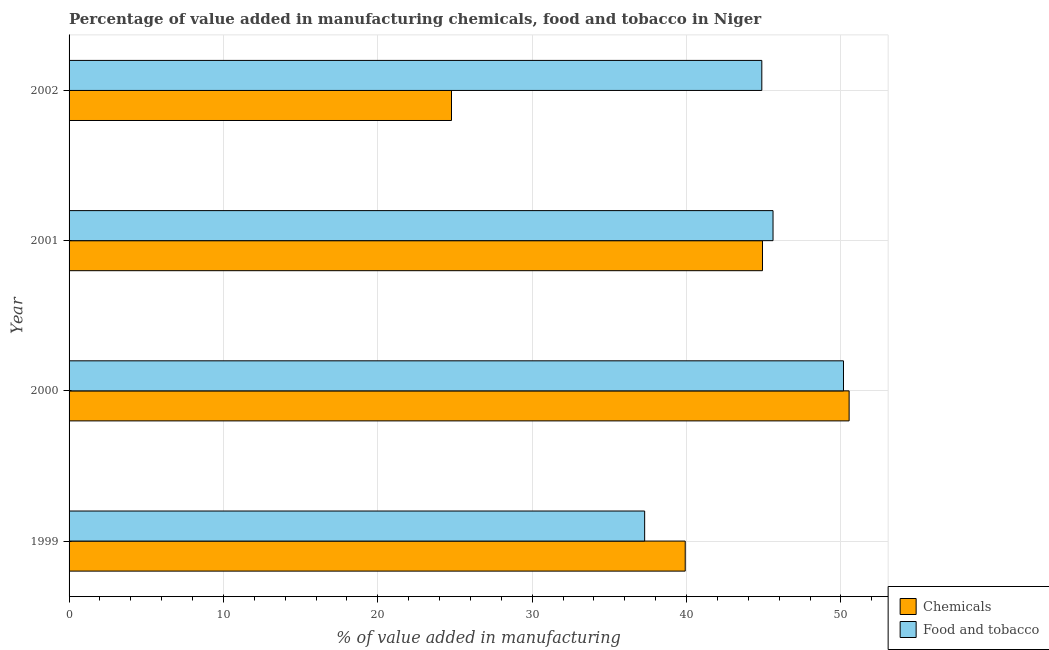Are the number of bars per tick equal to the number of legend labels?
Give a very brief answer. Yes. How many bars are there on the 2nd tick from the top?
Offer a very short reply. 2. What is the label of the 1st group of bars from the top?
Your answer should be very brief. 2002. In how many cases, is the number of bars for a given year not equal to the number of legend labels?
Offer a terse response. 0. What is the value added by  manufacturing chemicals in 2002?
Keep it short and to the point. 24.77. Across all years, what is the maximum value added by manufacturing food and tobacco?
Give a very brief answer. 50.16. Across all years, what is the minimum value added by  manufacturing chemicals?
Offer a terse response. 24.77. In which year was the value added by  manufacturing chemicals minimum?
Make the answer very short. 2002. What is the total value added by  manufacturing chemicals in the graph?
Give a very brief answer. 160.13. What is the difference between the value added by manufacturing food and tobacco in 2001 and that in 2002?
Offer a very short reply. 0.73. What is the difference between the value added by manufacturing food and tobacco in 2000 and the value added by  manufacturing chemicals in 2001?
Offer a terse response. 5.25. What is the average value added by manufacturing food and tobacco per year?
Your response must be concise. 44.48. In the year 2002, what is the difference between the value added by manufacturing food and tobacco and value added by  manufacturing chemicals?
Ensure brevity in your answer.  20.1. In how many years, is the value added by manufacturing food and tobacco greater than 26 %?
Ensure brevity in your answer.  4. What is the ratio of the value added by  manufacturing chemicals in 2000 to that in 2001?
Your answer should be compact. 1.12. Is the value added by manufacturing food and tobacco in 2000 less than that in 2001?
Keep it short and to the point. No. What is the difference between the highest and the second highest value added by manufacturing food and tobacco?
Ensure brevity in your answer.  4.56. What is the difference between the highest and the lowest value added by manufacturing food and tobacco?
Make the answer very short. 12.88. In how many years, is the value added by  manufacturing chemicals greater than the average value added by  manufacturing chemicals taken over all years?
Offer a terse response. 2. Is the sum of the value added by  manufacturing chemicals in 1999 and 2002 greater than the maximum value added by manufacturing food and tobacco across all years?
Keep it short and to the point. Yes. What does the 2nd bar from the top in 2001 represents?
Provide a succinct answer. Chemicals. What does the 1st bar from the bottom in 2000 represents?
Ensure brevity in your answer.  Chemicals. Are all the bars in the graph horizontal?
Offer a terse response. Yes. How many years are there in the graph?
Keep it short and to the point. 4. Are the values on the major ticks of X-axis written in scientific E-notation?
Your response must be concise. No. How many legend labels are there?
Ensure brevity in your answer.  2. What is the title of the graph?
Provide a succinct answer. Percentage of value added in manufacturing chemicals, food and tobacco in Niger. What is the label or title of the X-axis?
Ensure brevity in your answer.  % of value added in manufacturing. What is the label or title of the Y-axis?
Keep it short and to the point. Year. What is the % of value added in manufacturing of Chemicals in 1999?
Give a very brief answer. 39.91. What is the % of value added in manufacturing in Food and tobacco in 1999?
Make the answer very short. 37.28. What is the % of value added in manufacturing of Chemicals in 2000?
Your answer should be very brief. 50.53. What is the % of value added in manufacturing of Food and tobacco in 2000?
Your answer should be compact. 50.16. What is the % of value added in manufacturing in Chemicals in 2001?
Offer a very short reply. 44.92. What is the % of value added in manufacturing of Food and tobacco in 2001?
Your answer should be compact. 45.6. What is the % of value added in manufacturing of Chemicals in 2002?
Provide a succinct answer. 24.77. What is the % of value added in manufacturing in Food and tobacco in 2002?
Provide a succinct answer. 44.87. Across all years, what is the maximum % of value added in manufacturing of Chemicals?
Your response must be concise. 50.53. Across all years, what is the maximum % of value added in manufacturing in Food and tobacco?
Your answer should be very brief. 50.16. Across all years, what is the minimum % of value added in manufacturing in Chemicals?
Ensure brevity in your answer.  24.77. Across all years, what is the minimum % of value added in manufacturing of Food and tobacco?
Your response must be concise. 37.28. What is the total % of value added in manufacturing in Chemicals in the graph?
Provide a short and direct response. 160.13. What is the total % of value added in manufacturing in Food and tobacco in the graph?
Offer a very short reply. 177.92. What is the difference between the % of value added in manufacturing of Chemicals in 1999 and that in 2000?
Your answer should be compact. -10.62. What is the difference between the % of value added in manufacturing in Food and tobacco in 1999 and that in 2000?
Provide a succinct answer. -12.88. What is the difference between the % of value added in manufacturing of Chemicals in 1999 and that in 2001?
Your answer should be very brief. -5.01. What is the difference between the % of value added in manufacturing in Food and tobacco in 1999 and that in 2001?
Provide a succinct answer. -8.32. What is the difference between the % of value added in manufacturing in Chemicals in 1999 and that in 2002?
Your answer should be compact. 15.14. What is the difference between the % of value added in manufacturing in Food and tobacco in 1999 and that in 2002?
Offer a terse response. -7.59. What is the difference between the % of value added in manufacturing of Chemicals in 2000 and that in 2001?
Offer a very short reply. 5.61. What is the difference between the % of value added in manufacturing of Food and tobacco in 2000 and that in 2001?
Make the answer very short. 4.56. What is the difference between the % of value added in manufacturing in Chemicals in 2000 and that in 2002?
Keep it short and to the point. 25.76. What is the difference between the % of value added in manufacturing of Food and tobacco in 2000 and that in 2002?
Provide a succinct answer. 5.29. What is the difference between the % of value added in manufacturing in Chemicals in 2001 and that in 2002?
Provide a short and direct response. 20.14. What is the difference between the % of value added in manufacturing of Food and tobacco in 2001 and that in 2002?
Offer a very short reply. 0.73. What is the difference between the % of value added in manufacturing in Chemicals in 1999 and the % of value added in manufacturing in Food and tobacco in 2000?
Provide a short and direct response. -10.25. What is the difference between the % of value added in manufacturing in Chemicals in 1999 and the % of value added in manufacturing in Food and tobacco in 2001?
Offer a terse response. -5.69. What is the difference between the % of value added in manufacturing of Chemicals in 1999 and the % of value added in manufacturing of Food and tobacco in 2002?
Give a very brief answer. -4.96. What is the difference between the % of value added in manufacturing in Chemicals in 2000 and the % of value added in manufacturing in Food and tobacco in 2001?
Offer a terse response. 4.93. What is the difference between the % of value added in manufacturing in Chemicals in 2000 and the % of value added in manufacturing in Food and tobacco in 2002?
Provide a short and direct response. 5.66. What is the difference between the % of value added in manufacturing in Chemicals in 2001 and the % of value added in manufacturing in Food and tobacco in 2002?
Keep it short and to the point. 0.04. What is the average % of value added in manufacturing of Chemicals per year?
Provide a succinct answer. 40.03. What is the average % of value added in manufacturing in Food and tobacco per year?
Keep it short and to the point. 44.48. In the year 1999, what is the difference between the % of value added in manufacturing of Chemicals and % of value added in manufacturing of Food and tobacco?
Offer a terse response. 2.63. In the year 2000, what is the difference between the % of value added in manufacturing in Chemicals and % of value added in manufacturing in Food and tobacco?
Keep it short and to the point. 0.37. In the year 2001, what is the difference between the % of value added in manufacturing in Chemicals and % of value added in manufacturing in Food and tobacco?
Offer a very short reply. -0.68. In the year 2002, what is the difference between the % of value added in manufacturing in Chemicals and % of value added in manufacturing in Food and tobacco?
Provide a succinct answer. -20.1. What is the ratio of the % of value added in manufacturing of Chemicals in 1999 to that in 2000?
Your response must be concise. 0.79. What is the ratio of the % of value added in manufacturing in Food and tobacco in 1999 to that in 2000?
Your answer should be very brief. 0.74. What is the ratio of the % of value added in manufacturing of Chemicals in 1999 to that in 2001?
Your answer should be very brief. 0.89. What is the ratio of the % of value added in manufacturing in Food and tobacco in 1999 to that in 2001?
Your answer should be compact. 0.82. What is the ratio of the % of value added in manufacturing of Chemicals in 1999 to that in 2002?
Ensure brevity in your answer.  1.61. What is the ratio of the % of value added in manufacturing in Food and tobacco in 1999 to that in 2002?
Offer a very short reply. 0.83. What is the ratio of the % of value added in manufacturing in Chemicals in 2000 to that in 2001?
Give a very brief answer. 1.12. What is the ratio of the % of value added in manufacturing of Food and tobacco in 2000 to that in 2001?
Your response must be concise. 1.1. What is the ratio of the % of value added in manufacturing of Chemicals in 2000 to that in 2002?
Provide a succinct answer. 2.04. What is the ratio of the % of value added in manufacturing of Food and tobacco in 2000 to that in 2002?
Provide a succinct answer. 1.12. What is the ratio of the % of value added in manufacturing of Chemicals in 2001 to that in 2002?
Provide a short and direct response. 1.81. What is the ratio of the % of value added in manufacturing of Food and tobacco in 2001 to that in 2002?
Provide a succinct answer. 1.02. What is the difference between the highest and the second highest % of value added in manufacturing in Chemicals?
Your answer should be very brief. 5.61. What is the difference between the highest and the second highest % of value added in manufacturing of Food and tobacco?
Provide a succinct answer. 4.56. What is the difference between the highest and the lowest % of value added in manufacturing in Chemicals?
Offer a terse response. 25.76. What is the difference between the highest and the lowest % of value added in manufacturing of Food and tobacco?
Offer a very short reply. 12.88. 